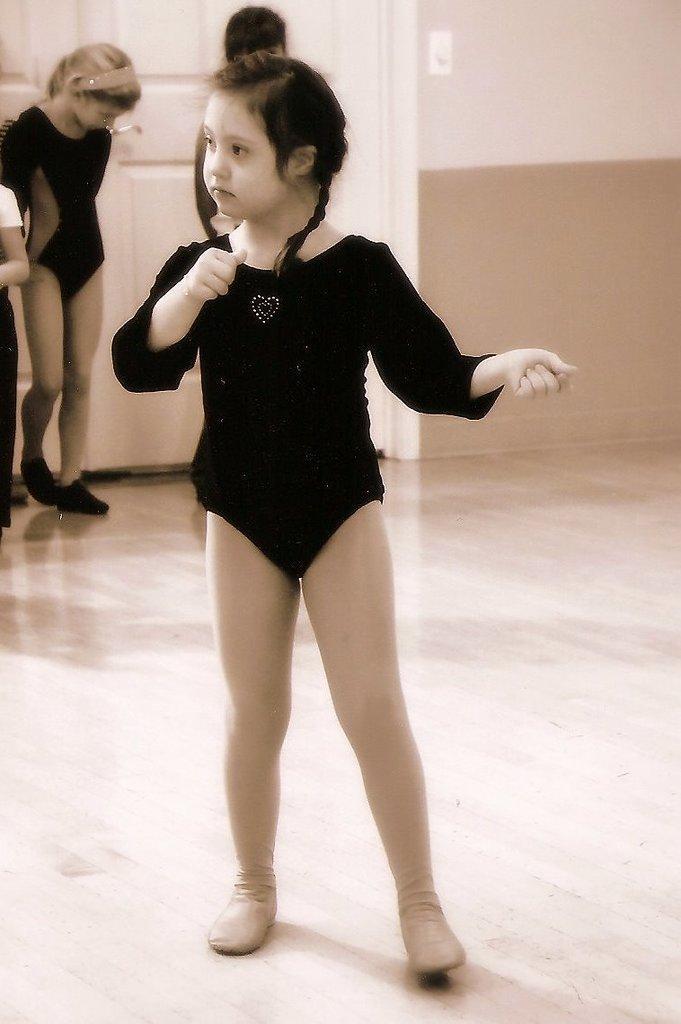Could you give a brief overview of what you see in this image? In the middle of this image, there is a girl in a black color dress, doing a performance on a floor. In the background, there are three children, white color doors and a wall. 